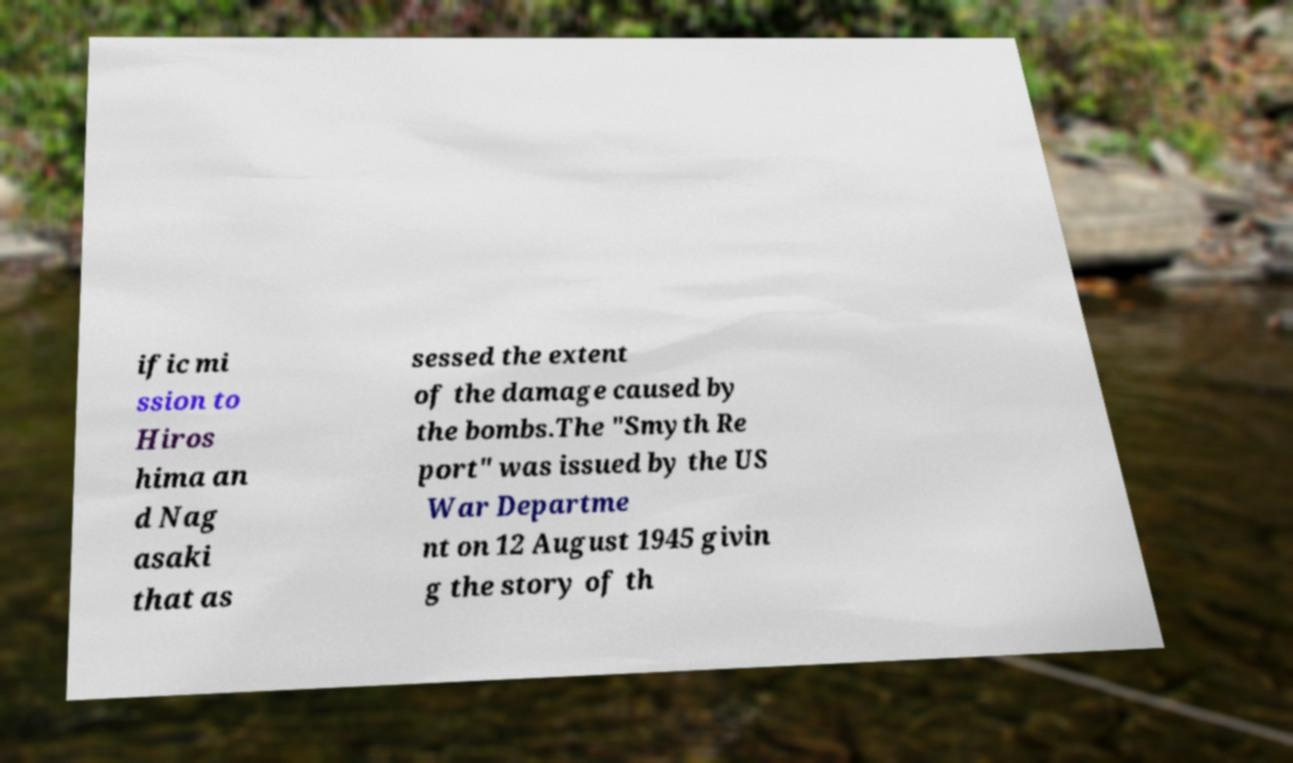Could you assist in decoding the text presented in this image and type it out clearly? ific mi ssion to Hiros hima an d Nag asaki that as sessed the extent of the damage caused by the bombs.The "Smyth Re port" was issued by the US War Departme nt on 12 August 1945 givin g the story of th 